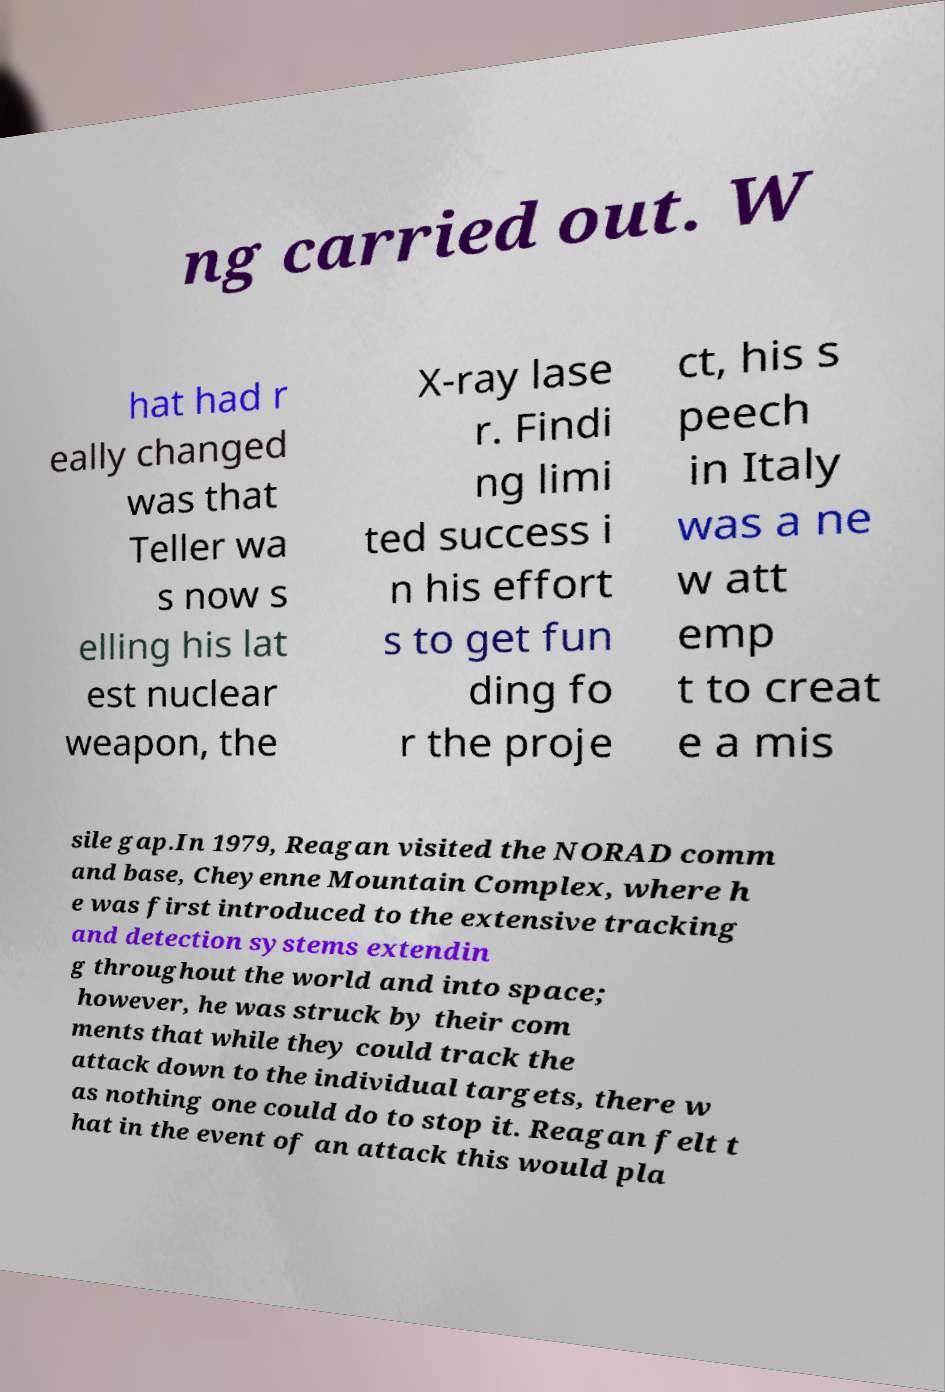I need the written content from this picture converted into text. Can you do that? ng carried out. W hat had r eally changed was that Teller wa s now s elling his lat est nuclear weapon, the X-ray lase r. Findi ng limi ted success i n his effort s to get fun ding fo r the proje ct, his s peech in Italy was a ne w att emp t to creat e a mis sile gap.In 1979, Reagan visited the NORAD comm and base, Cheyenne Mountain Complex, where h e was first introduced to the extensive tracking and detection systems extendin g throughout the world and into space; however, he was struck by their com ments that while they could track the attack down to the individual targets, there w as nothing one could do to stop it. Reagan felt t hat in the event of an attack this would pla 